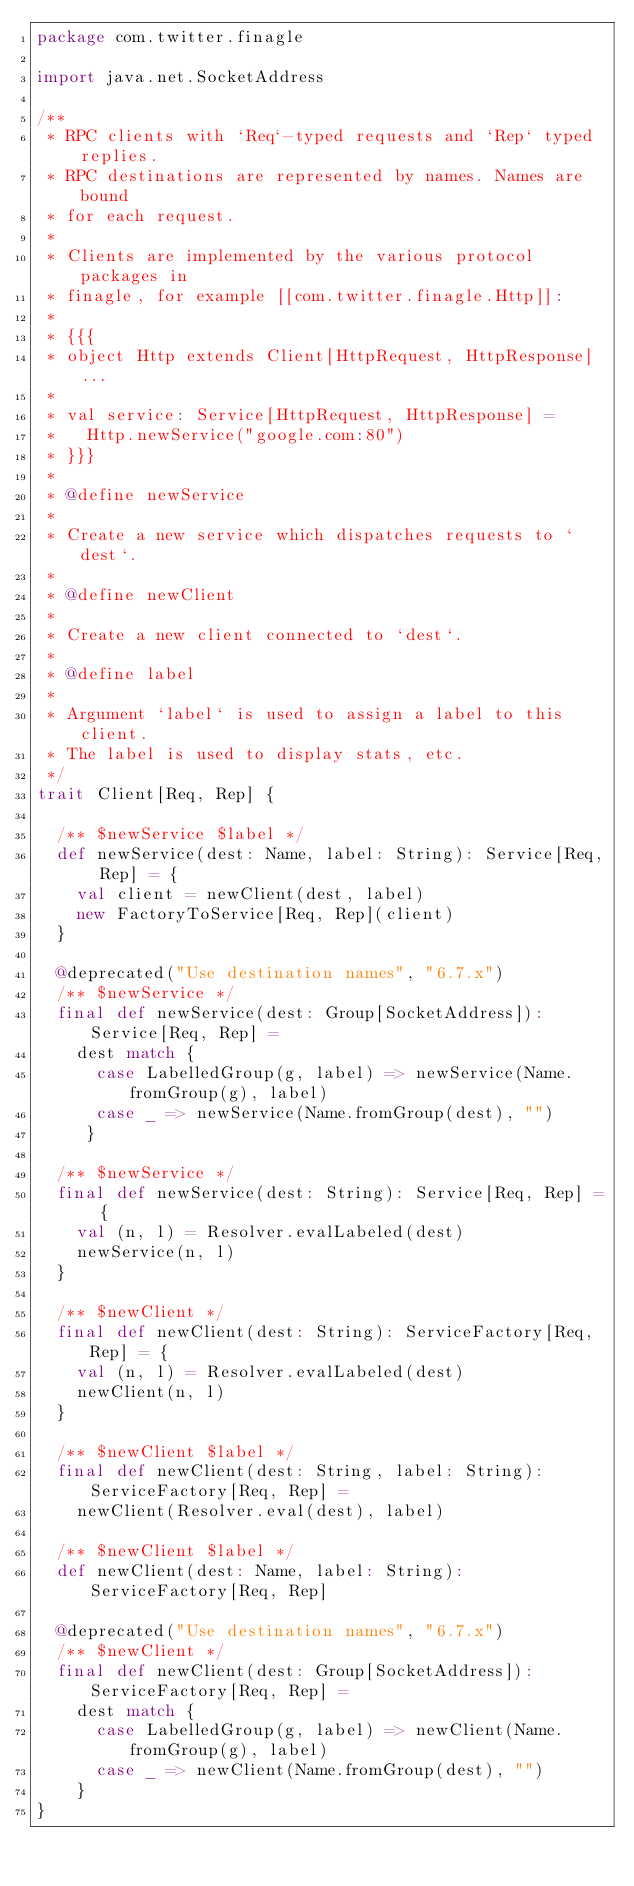Convert code to text. <code><loc_0><loc_0><loc_500><loc_500><_Scala_>package com.twitter.finagle

import java.net.SocketAddress

/**
 * RPC clients with `Req`-typed requests and `Rep` typed replies.
 * RPC destinations are represented by names. Names are bound
 * for each request.
 *
 * Clients are implemented by the various protocol packages in
 * finagle, for example [[com.twitter.finagle.Http]]:
 *
 * {{{
 * object Http extends Client[HttpRequest, HttpResponse] ...
 *
 * val service: Service[HttpRequest, HttpResponse] =
 *   Http.newService("google.com:80")
 * }}}
 *
 * @define newService
 *
 * Create a new service which dispatches requests to `dest`.
 *
 * @define newClient
 *
 * Create a new client connected to `dest`.
 *
 * @define label
 *
 * Argument `label` is used to assign a label to this client.
 * The label is used to display stats, etc.
 */
trait Client[Req, Rep] {

  /** $newService $label */
  def newService(dest: Name, label: String): Service[Req, Rep] = {
    val client = newClient(dest, label)
    new FactoryToService[Req, Rep](client)
  }

  @deprecated("Use destination names", "6.7.x")
  /** $newService */
  final def newService(dest: Group[SocketAddress]): Service[Req, Rep] =
    dest match {
      case LabelledGroup(g, label) => newService(Name.fromGroup(g), label)
      case _ => newService(Name.fromGroup(dest), "")
     }

  /** $newService */
  final def newService(dest: String): Service[Req, Rep] = {
    val (n, l) = Resolver.evalLabeled(dest)
    newService(n, l)
  }

  /** $newClient */
  final def newClient(dest: String): ServiceFactory[Req, Rep] = {
    val (n, l) = Resolver.evalLabeled(dest)
    newClient(n, l)
  }

  /** $newClient $label */
  final def newClient(dest: String, label: String): ServiceFactory[Req, Rep] =
    newClient(Resolver.eval(dest), label)

  /** $newClient $label */
  def newClient(dest: Name, label: String): ServiceFactory[Req, Rep]

  @deprecated("Use destination names", "6.7.x")
  /** $newClient */
  final def newClient(dest: Group[SocketAddress]): ServiceFactory[Req, Rep] =
    dest match {
      case LabelledGroup(g, label) => newClient(Name.fromGroup(g), label)
      case _ => newClient(Name.fromGroup(dest), "")
    }
}
</code> 